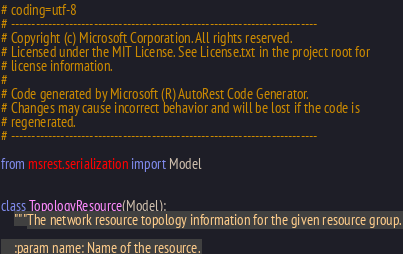<code> <loc_0><loc_0><loc_500><loc_500><_Python_># coding=utf-8
# --------------------------------------------------------------------------
# Copyright (c) Microsoft Corporation. All rights reserved.
# Licensed under the MIT License. See License.txt in the project root for
# license information.
#
# Code generated by Microsoft (R) AutoRest Code Generator.
# Changes may cause incorrect behavior and will be lost if the code is
# regenerated.
# --------------------------------------------------------------------------

from msrest.serialization import Model


class TopologyResource(Model):
    """The network resource topology information for the given resource group.

    :param name: Name of the resource.</code> 